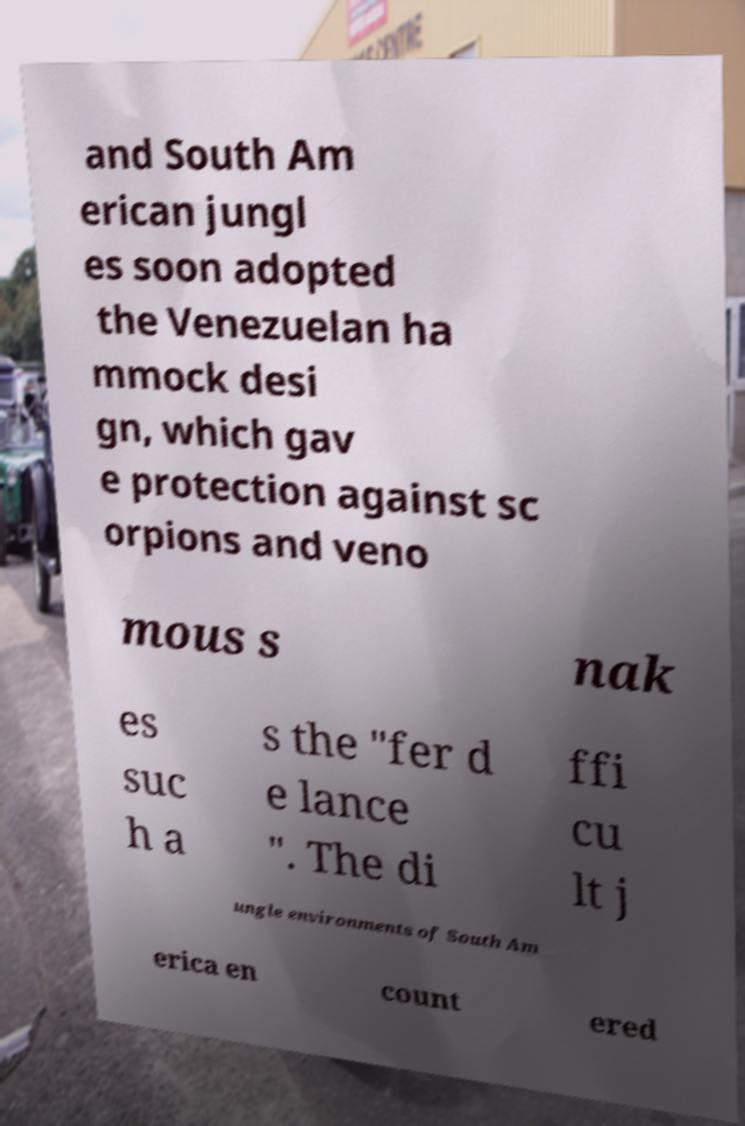Please read and relay the text visible in this image. What does it say? and South Am erican jungl es soon adopted the Venezuelan ha mmock desi gn, which gav e protection against sc orpions and veno mous s nak es suc h a s the "fer d e lance ". The di ffi cu lt j ungle environments of South Am erica en count ered 